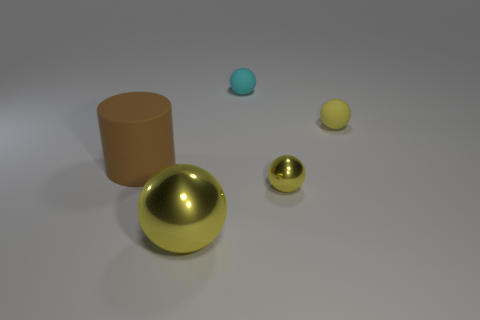What kind of material do the objects seem to be made of, and which one stands out the most? The objects appear to be made of various matte and shiny materials. The large gold sphere stands out due to its reflective surface and size. 